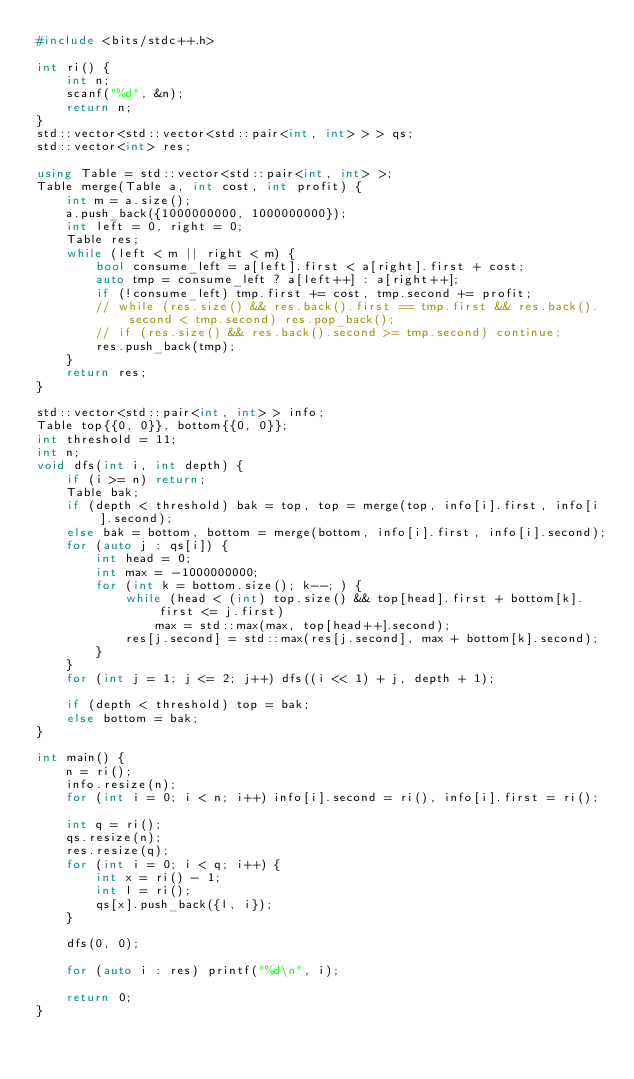Convert code to text. <code><loc_0><loc_0><loc_500><loc_500><_C++_>#include <bits/stdc++.h>

int ri() {
	int n;
	scanf("%d", &n);
	return n;
}
std::vector<std::vector<std::pair<int, int> > > qs;
std::vector<int> res;

using Table = std::vector<std::pair<int, int> >;
Table merge(Table a, int cost, int profit) {
	int m = a.size();
	a.push_back({1000000000, 1000000000});
	int left = 0, right = 0;
	Table res;
	while (left < m || right < m) {
		bool consume_left = a[left].first < a[right].first + cost;
		auto tmp = consume_left ? a[left++] : a[right++];
		if (!consume_left) tmp.first += cost, tmp.second += profit;
		// while (res.size() && res.back().first == tmp.first && res.back().second < tmp.second) res.pop_back();
		// if (res.size() && res.back().second >= tmp.second) continue;
		res.push_back(tmp);
	}
	return res;
}

std::vector<std::pair<int, int> > info;
Table top{{0, 0}}, bottom{{0, 0}};
int threshold = 11;
int n;
void dfs(int i, int depth) {
	if (i >= n) return;
	Table bak;
	if (depth < threshold) bak = top, top = merge(top, info[i].first, info[i].second);
	else bak = bottom, bottom = merge(bottom, info[i].first, info[i].second);
	for (auto j : qs[i]) {
		int head = 0;
		int max = -1000000000;
		for (int k = bottom.size(); k--; ) {
			while (head < (int) top.size() && top[head].first + bottom[k].first <= j.first)
				max = std::max(max, top[head++].second);
			res[j.second] = std::max(res[j.second], max + bottom[k].second);
		}
	}
	for (int j = 1; j <= 2; j++) dfs((i << 1) + j, depth + 1);
	
	if (depth < threshold) top = bak;
	else bottom = bak;
}

int main() {
	n = ri();
	info.resize(n);
	for (int i = 0; i < n; i++) info[i].second = ri(), info[i].first = ri();
	
	int q = ri();
	qs.resize(n);
	res.resize(q);
	for (int i = 0; i < q; i++) {
		int x = ri() - 1;
		int l = ri();
		qs[x].push_back({l, i});
	}
	
	dfs(0, 0);
	
	for (auto i : res) printf("%d\n", i);
	
	return 0;
}
</code> 